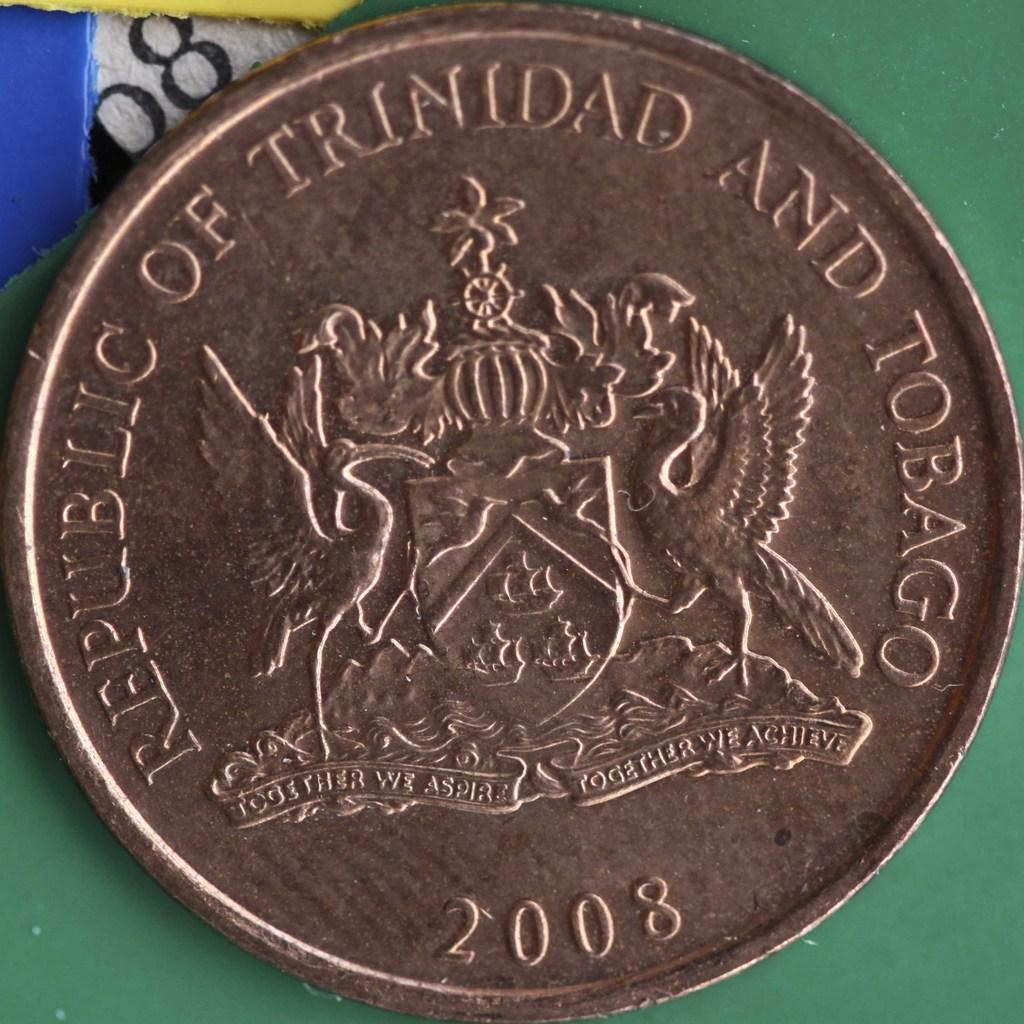<image>
Render a clear and concise summary of the photo. a close up of a coin from Trinidad and Tobago 2008 